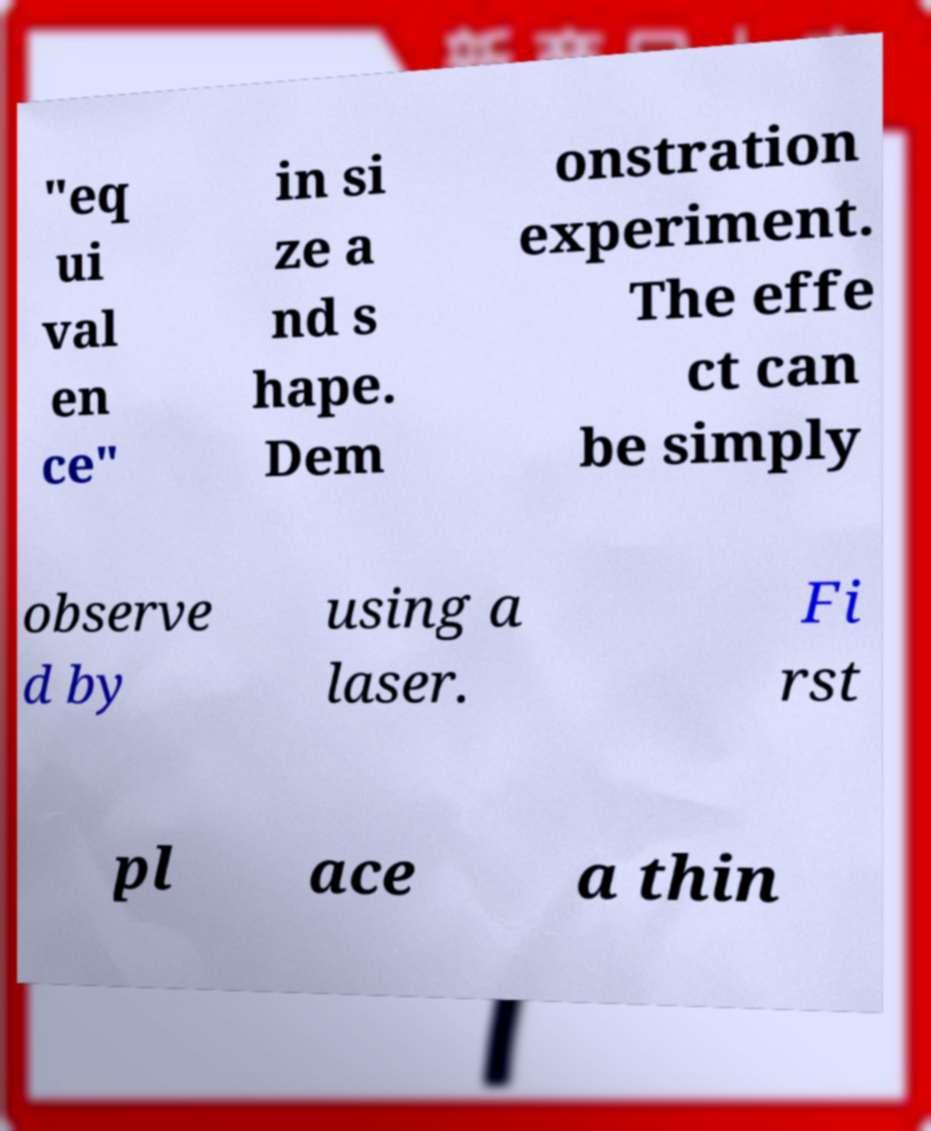Please identify and transcribe the text found in this image. "eq ui val en ce" in si ze a nd s hape. Dem onstration experiment. The effe ct can be simply observe d by using a laser. Fi rst pl ace a thin 